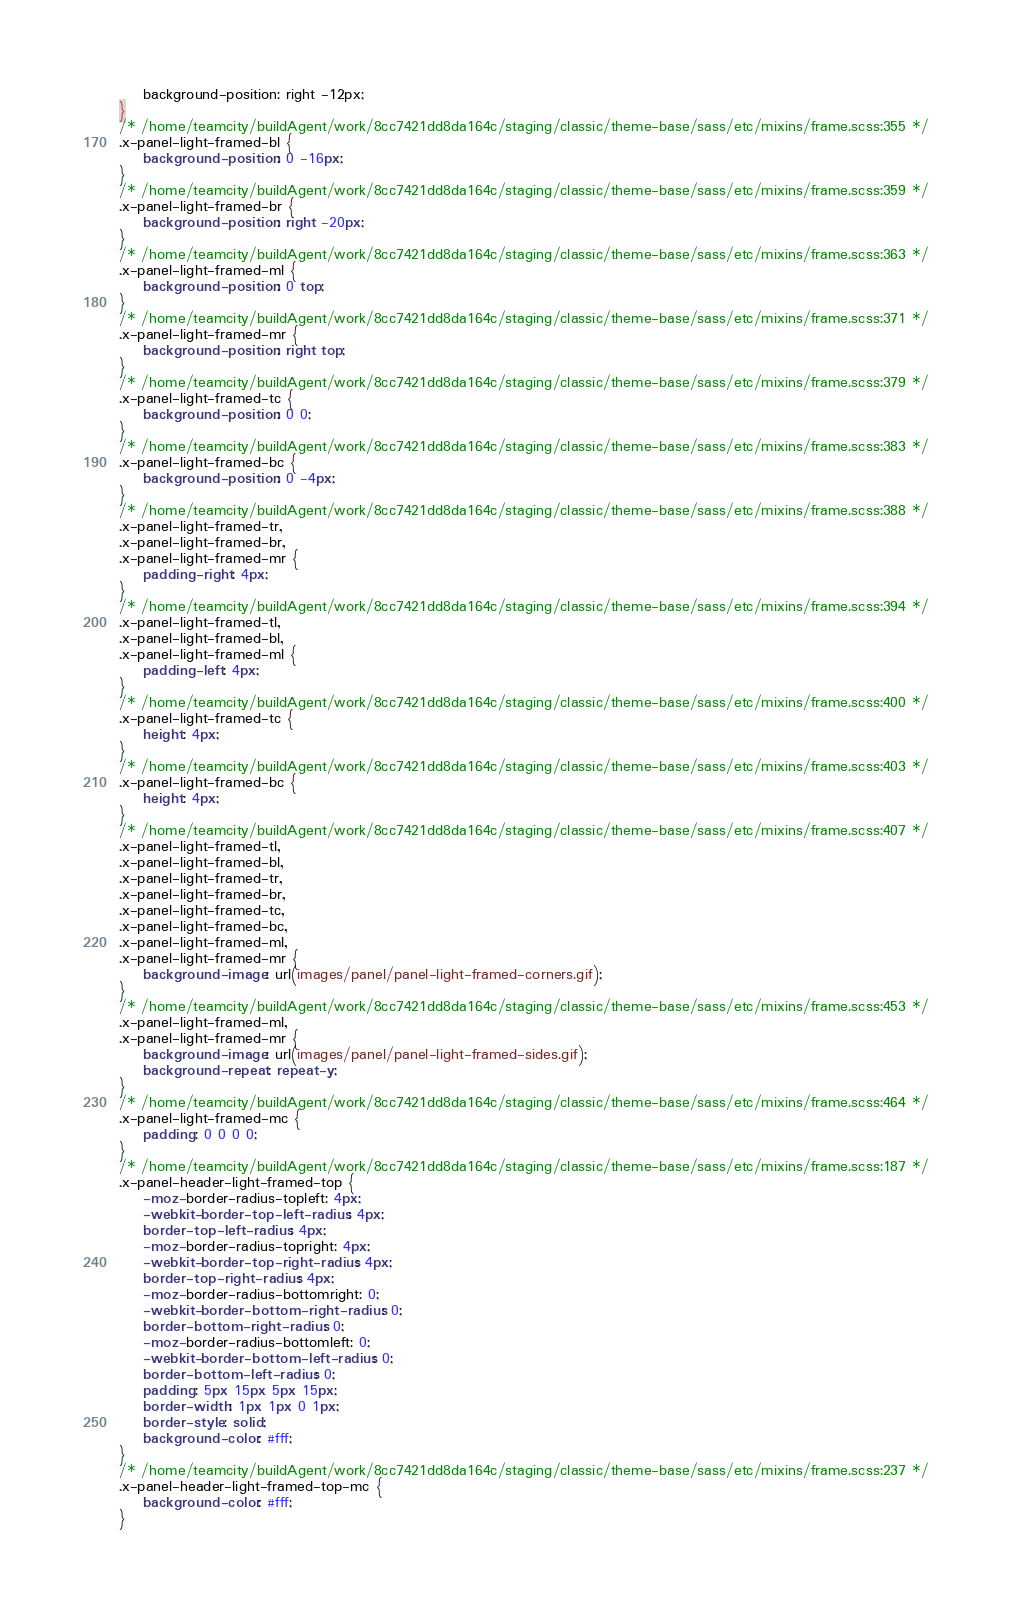Convert code to text. <code><loc_0><loc_0><loc_500><loc_500><_CSS_>    background-position: right -12px;
}
/* /home/teamcity/buildAgent/work/8cc7421dd8da164c/staging/classic/theme-base/sass/etc/mixins/frame.scss:355 */
.x-panel-light-framed-bl {
    background-position: 0 -16px;
}
/* /home/teamcity/buildAgent/work/8cc7421dd8da164c/staging/classic/theme-base/sass/etc/mixins/frame.scss:359 */
.x-panel-light-framed-br {
    background-position: right -20px;
}
/* /home/teamcity/buildAgent/work/8cc7421dd8da164c/staging/classic/theme-base/sass/etc/mixins/frame.scss:363 */
.x-panel-light-framed-ml {
    background-position: 0 top;
}
/* /home/teamcity/buildAgent/work/8cc7421dd8da164c/staging/classic/theme-base/sass/etc/mixins/frame.scss:371 */
.x-panel-light-framed-mr {
    background-position: right top;
}
/* /home/teamcity/buildAgent/work/8cc7421dd8da164c/staging/classic/theme-base/sass/etc/mixins/frame.scss:379 */
.x-panel-light-framed-tc {
    background-position: 0 0;
}
/* /home/teamcity/buildAgent/work/8cc7421dd8da164c/staging/classic/theme-base/sass/etc/mixins/frame.scss:383 */
.x-panel-light-framed-bc {
    background-position: 0 -4px;
}
/* /home/teamcity/buildAgent/work/8cc7421dd8da164c/staging/classic/theme-base/sass/etc/mixins/frame.scss:388 */
.x-panel-light-framed-tr,
.x-panel-light-framed-br,
.x-panel-light-framed-mr {
    padding-right: 4px;
}
/* /home/teamcity/buildAgent/work/8cc7421dd8da164c/staging/classic/theme-base/sass/etc/mixins/frame.scss:394 */
.x-panel-light-framed-tl,
.x-panel-light-framed-bl,
.x-panel-light-framed-ml {
    padding-left: 4px;
}
/* /home/teamcity/buildAgent/work/8cc7421dd8da164c/staging/classic/theme-base/sass/etc/mixins/frame.scss:400 */
.x-panel-light-framed-tc {
    height: 4px;
}
/* /home/teamcity/buildAgent/work/8cc7421dd8da164c/staging/classic/theme-base/sass/etc/mixins/frame.scss:403 */
.x-panel-light-framed-bc {
    height: 4px;
}
/* /home/teamcity/buildAgent/work/8cc7421dd8da164c/staging/classic/theme-base/sass/etc/mixins/frame.scss:407 */
.x-panel-light-framed-tl,
.x-panel-light-framed-bl,
.x-panel-light-framed-tr,
.x-panel-light-framed-br,
.x-panel-light-framed-tc,
.x-panel-light-framed-bc,
.x-panel-light-framed-ml,
.x-panel-light-framed-mr {
    background-image: url(images/panel/panel-light-framed-corners.gif);
}
/* /home/teamcity/buildAgent/work/8cc7421dd8da164c/staging/classic/theme-base/sass/etc/mixins/frame.scss:453 */
.x-panel-light-framed-ml,
.x-panel-light-framed-mr {
    background-image: url(images/panel/panel-light-framed-sides.gif);
    background-repeat: repeat-y;
}
/* /home/teamcity/buildAgent/work/8cc7421dd8da164c/staging/classic/theme-base/sass/etc/mixins/frame.scss:464 */
.x-panel-light-framed-mc {
    padding: 0 0 0 0;
}
/* /home/teamcity/buildAgent/work/8cc7421dd8da164c/staging/classic/theme-base/sass/etc/mixins/frame.scss:187 */
.x-panel-header-light-framed-top {
    -moz-border-radius-topleft: 4px;
    -webkit-border-top-left-radius: 4px;
    border-top-left-radius: 4px;
    -moz-border-radius-topright: 4px;
    -webkit-border-top-right-radius: 4px;
    border-top-right-radius: 4px;
    -moz-border-radius-bottomright: 0;
    -webkit-border-bottom-right-radius: 0;
    border-bottom-right-radius: 0;
    -moz-border-radius-bottomleft: 0;
    -webkit-border-bottom-left-radius: 0;
    border-bottom-left-radius: 0;
    padding: 5px 15px 5px 15px;
    border-width: 1px 1px 0 1px;
    border-style: solid;
    background-color: #fff;
}
/* /home/teamcity/buildAgent/work/8cc7421dd8da164c/staging/classic/theme-base/sass/etc/mixins/frame.scss:237 */
.x-panel-header-light-framed-top-mc {
    background-color: #fff;
}</code> 